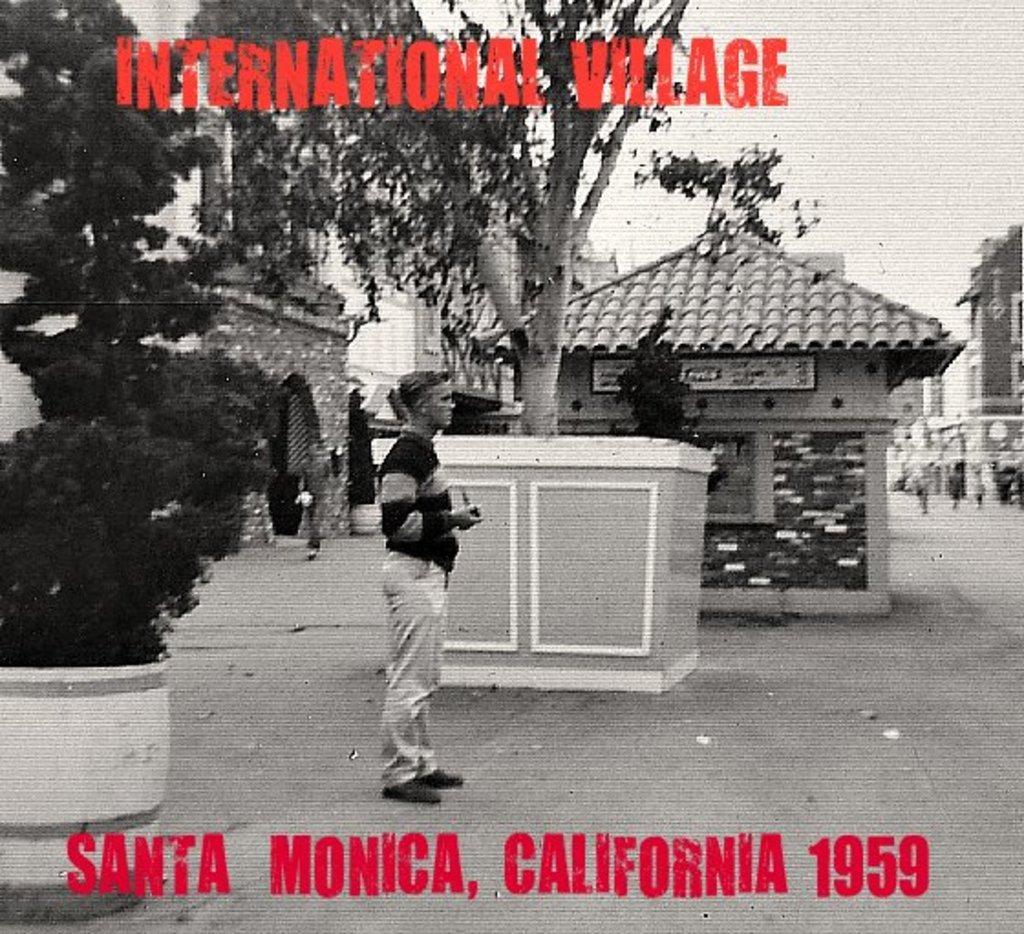Please provide a concise description of this image. Something written on this poster. On this poster we can see trees, buildings and person. 